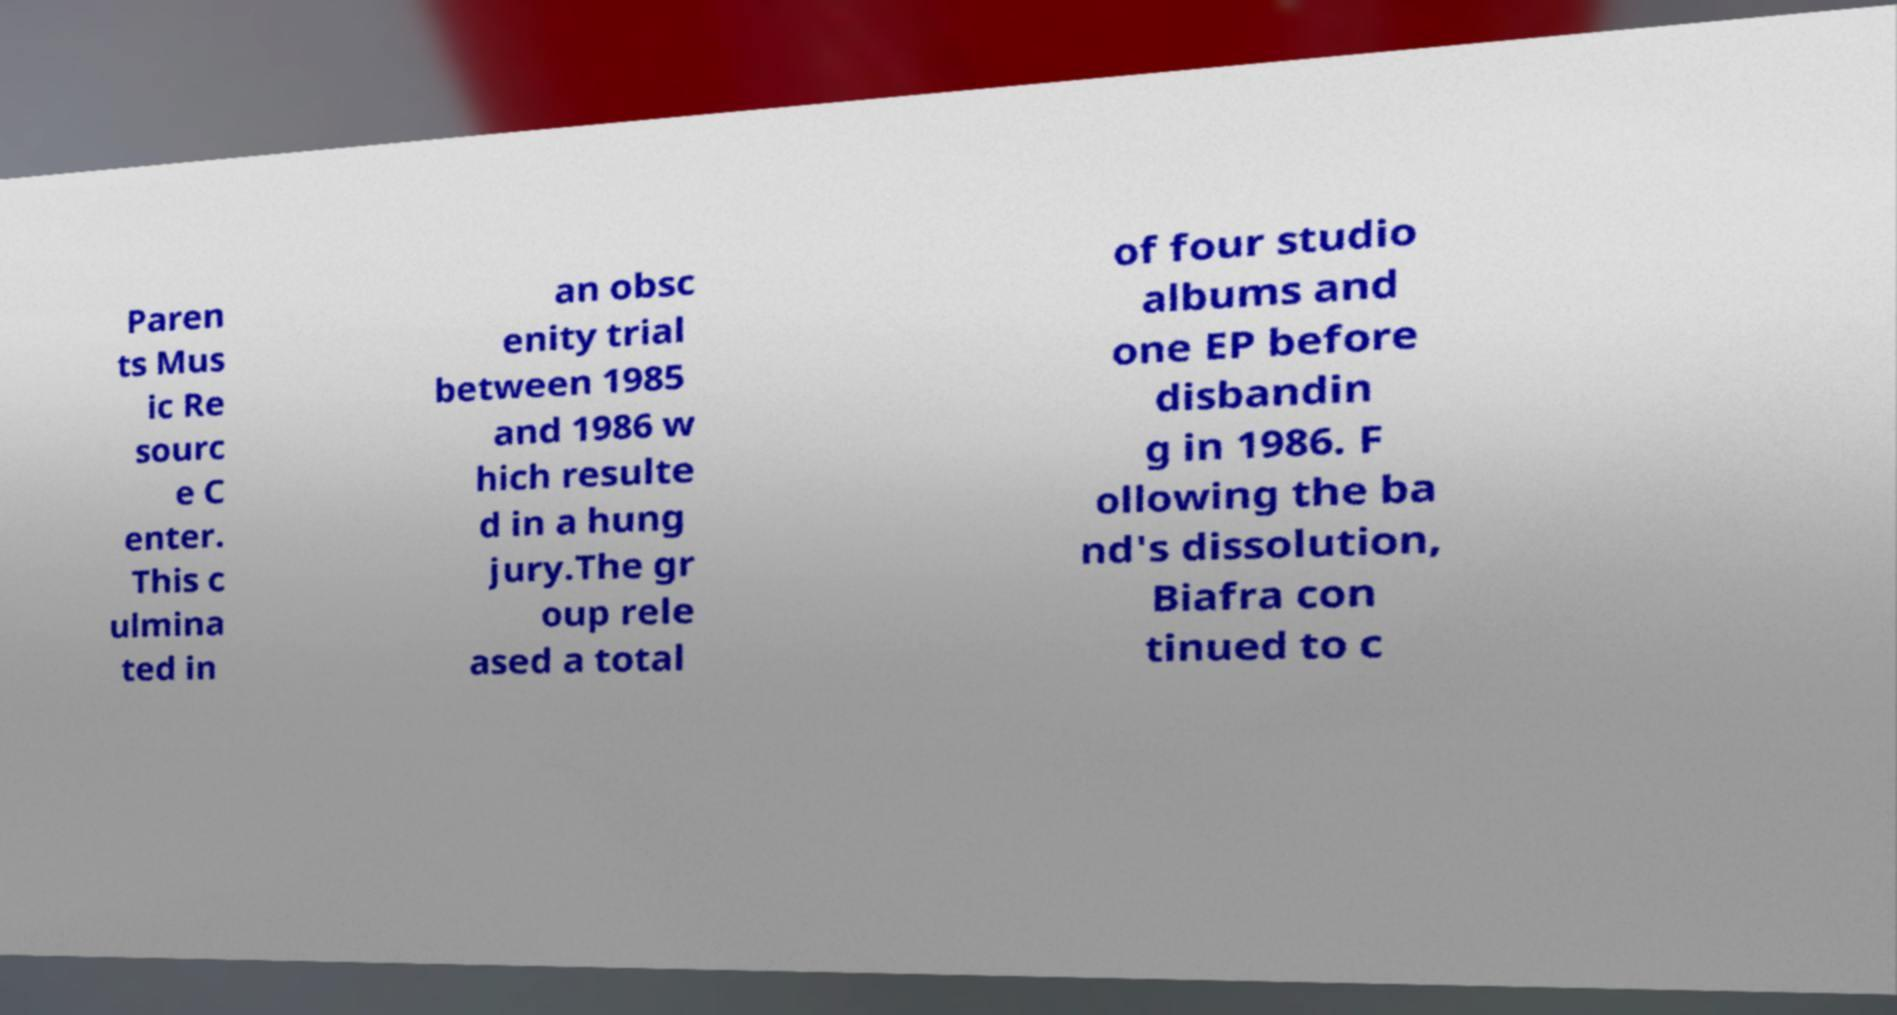What messages or text are displayed in this image? I need them in a readable, typed format. Paren ts Mus ic Re sourc e C enter. This c ulmina ted in an obsc enity trial between 1985 and 1986 w hich resulte d in a hung jury.The gr oup rele ased a total of four studio albums and one EP before disbandin g in 1986. F ollowing the ba nd's dissolution, Biafra con tinued to c 